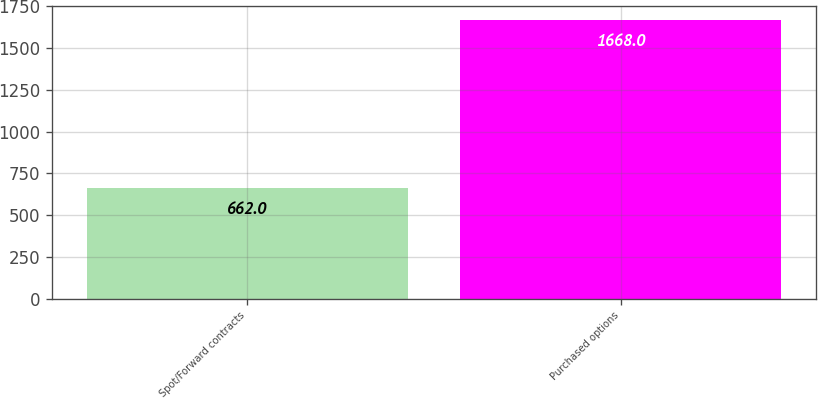Convert chart. <chart><loc_0><loc_0><loc_500><loc_500><bar_chart><fcel>Spot/Forward contracts<fcel>Purchased options<nl><fcel>662<fcel>1668<nl></chart> 